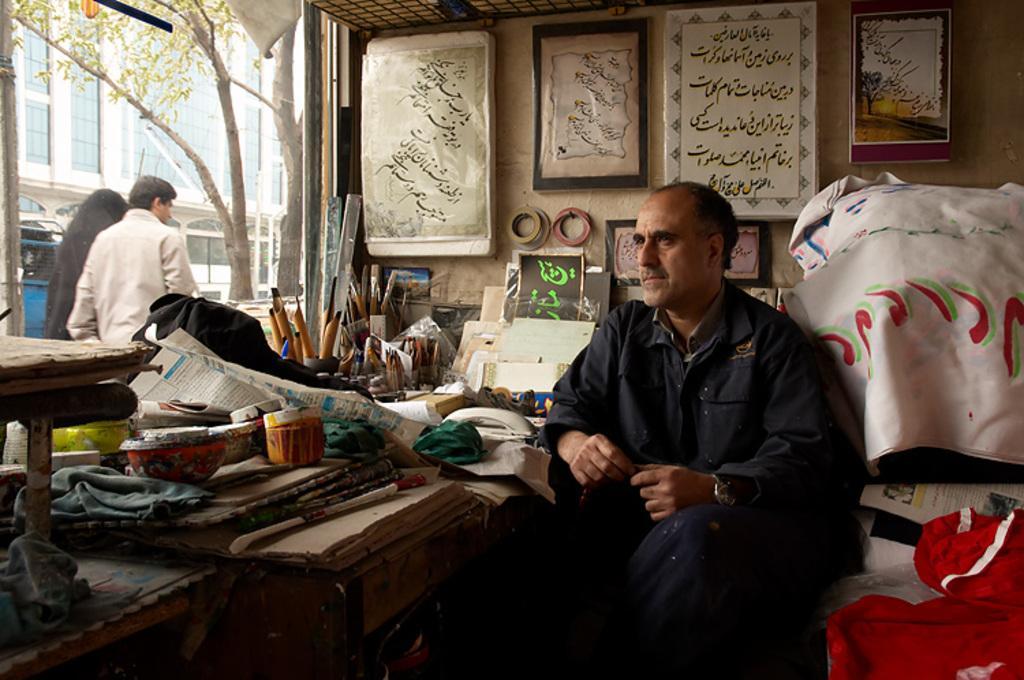Can you describe this image briefly? In this image in front there is a person. Beside him there are few objects. In the background of the image there are photo frames on the wall. On the left side of the image there are two people. Behind them there are trees, buildings. 